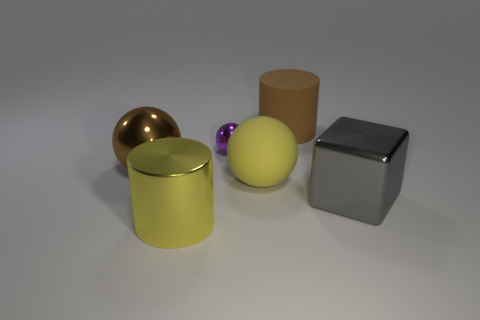Add 4 large red balls. How many objects exist? 10 Subtract all purple balls. Subtract all yellow blocks. How many balls are left? 2 Subtract all blocks. How many objects are left? 5 Add 4 big spheres. How many big spheres are left? 6 Add 4 tiny yellow cylinders. How many tiny yellow cylinders exist? 4 Subtract 0 red cylinders. How many objects are left? 6 Subtract all shiny spheres. Subtract all blue matte balls. How many objects are left? 4 